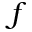<formula> <loc_0><loc_0><loc_500><loc_500>f</formula> 